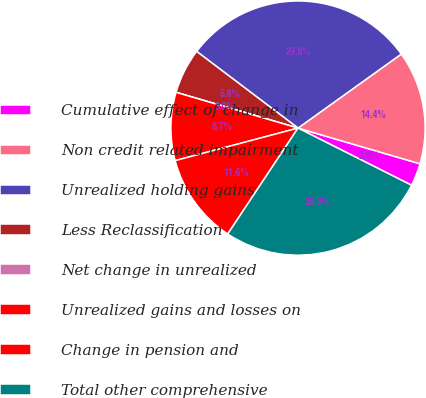<chart> <loc_0><loc_0><loc_500><loc_500><pie_chart><fcel>Cumulative effect of change in<fcel>Non credit related impairment<fcel>Unrealized holding gains<fcel>Less Reclassification<fcel>Net change in unrealized<fcel>Unrealized gains and losses on<fcel>Change in pension and<fcel>Total other comprehensive<nl><fcel>2.89%<fcel>14.43%<fcel>29.79%<fcel>5.77%<fcel>0.0%<fcel>8.66%<fcel>11.55%<fcel>26.9%<nl></chart> 